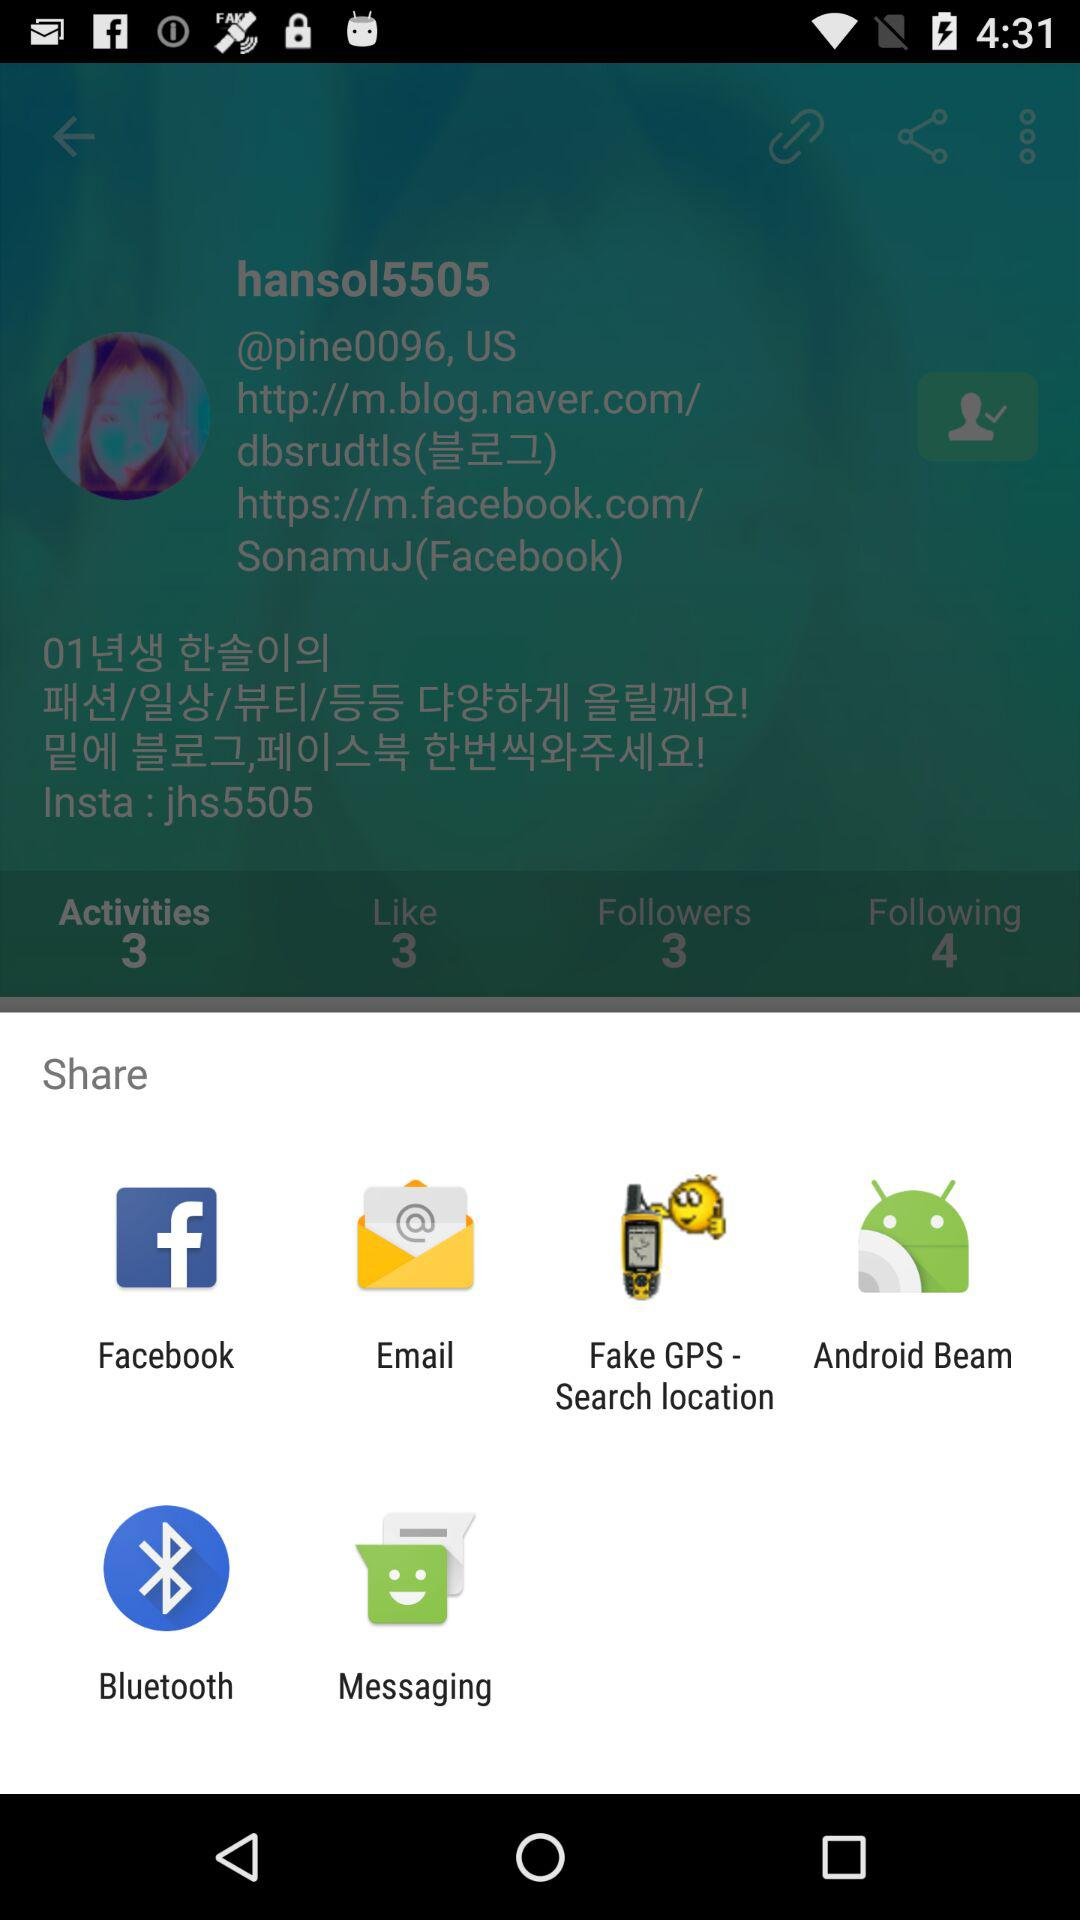What is the total number of followers present? There are a total of 3 followers present. 